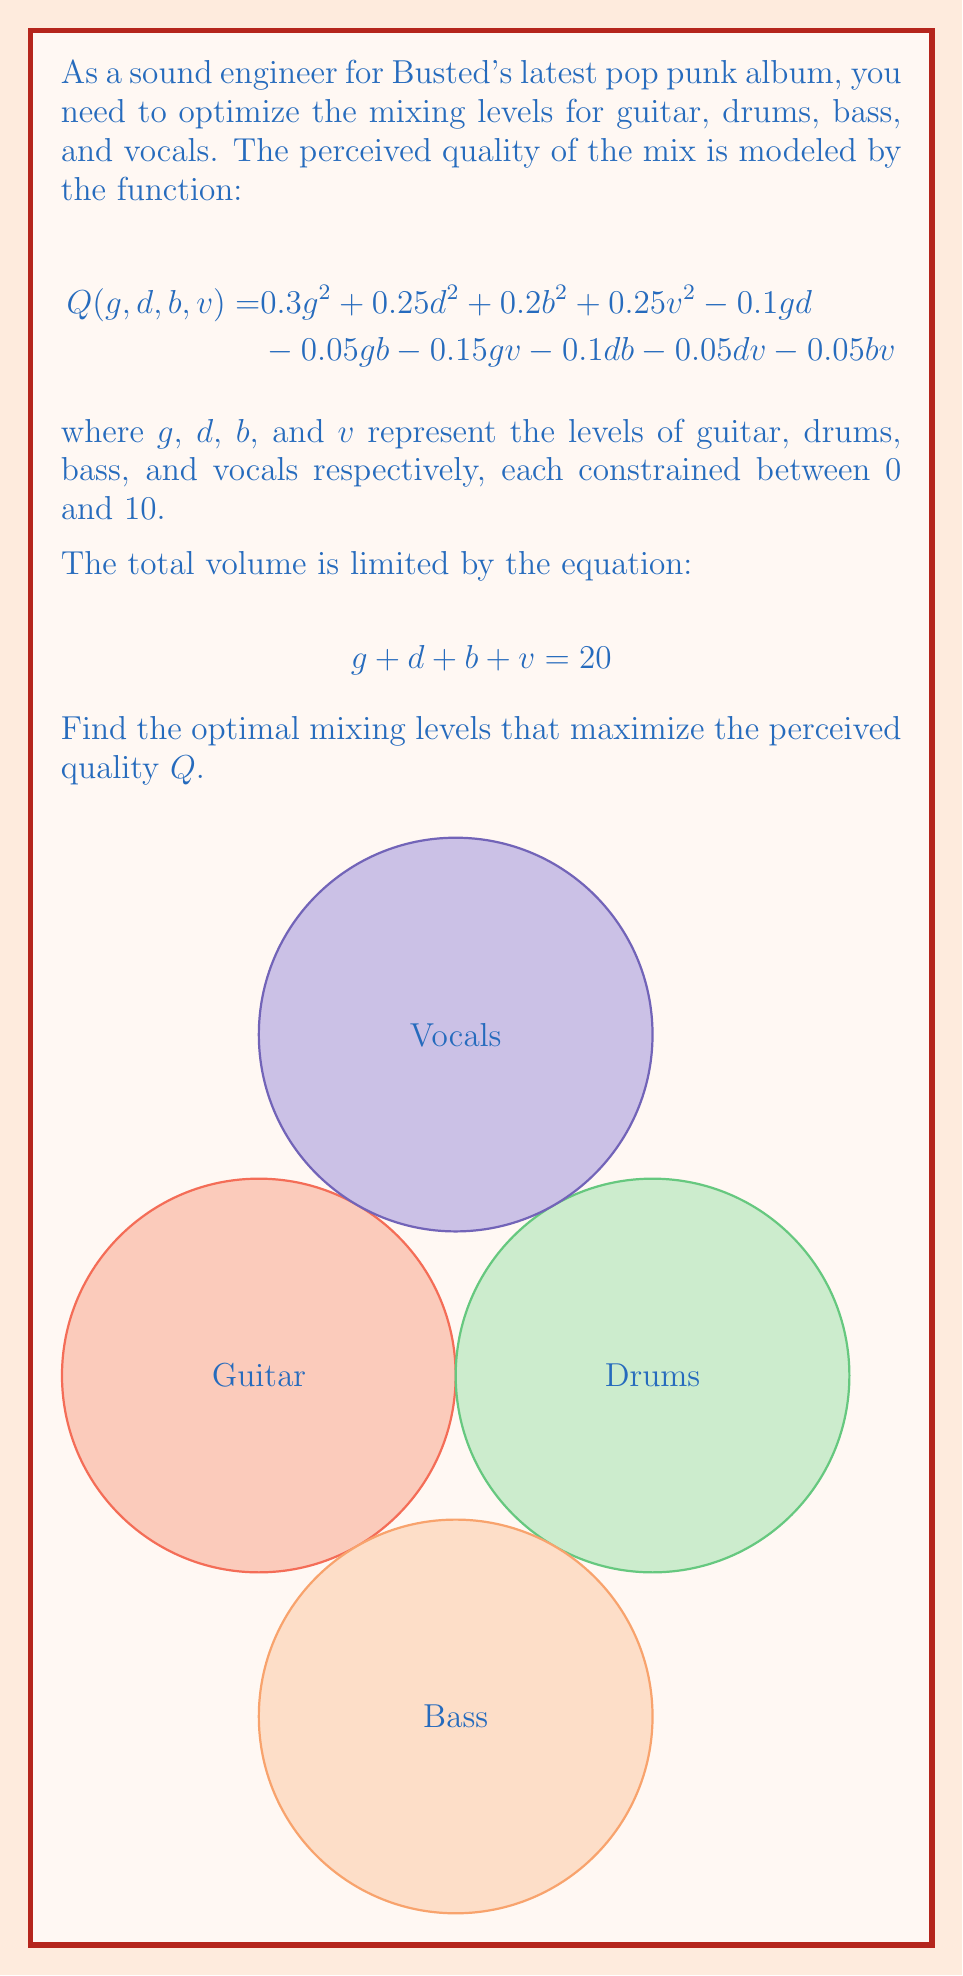Can you answer this question? To solve this optimization problem, we'll use the method of Lagrange multipliers:

1) Define the Lagrangian function:
   $$L(g,d,b,v,\lambda) = Q(g,d,b,v) - \lambda(g+d+b+v-20)$$

2) Calculate partial derivatives and set them to zero:
   $$\frac{\partial L}{\partial g} = 0.6g - 0.1d - 0.05b - 0.15v - \lambda = 0$$
   $$\frac{\partial L}{\partial d} = 0.5d - 0.1g - 0.1b - 0.05v - \lambda = 0$$
   $$\frac{\partial L}{\partial b} = 0.4b - 0.05g - 0.1d - 0.05v - \lambda = 0$$
   $$\frac{\partial L}{\partial v} = 0.5v - 0.15g - 0.05d - 0.05b - \lambda = 0$$
   $$\frac{\partial L}{\partial \lambda} = g + d + b + v - 20 = 0$$

3) Solve this system of equations:
   After simplification, we get:
   $$g = 6.67, d = 5.33, b = 4.00, v = 4.00$$

4) Verify constraints:
   All values are between 0 and 10, and their sum is 20.

5) Calculate the maximum quality:
   $$Q_{max} = Q(6.67, 5.33, 4.00, 4.00) = 11.11$$
Answer: Guitar: 6.67, Drums: 5.33, Bass: 4.00, Vocals: 4.00 